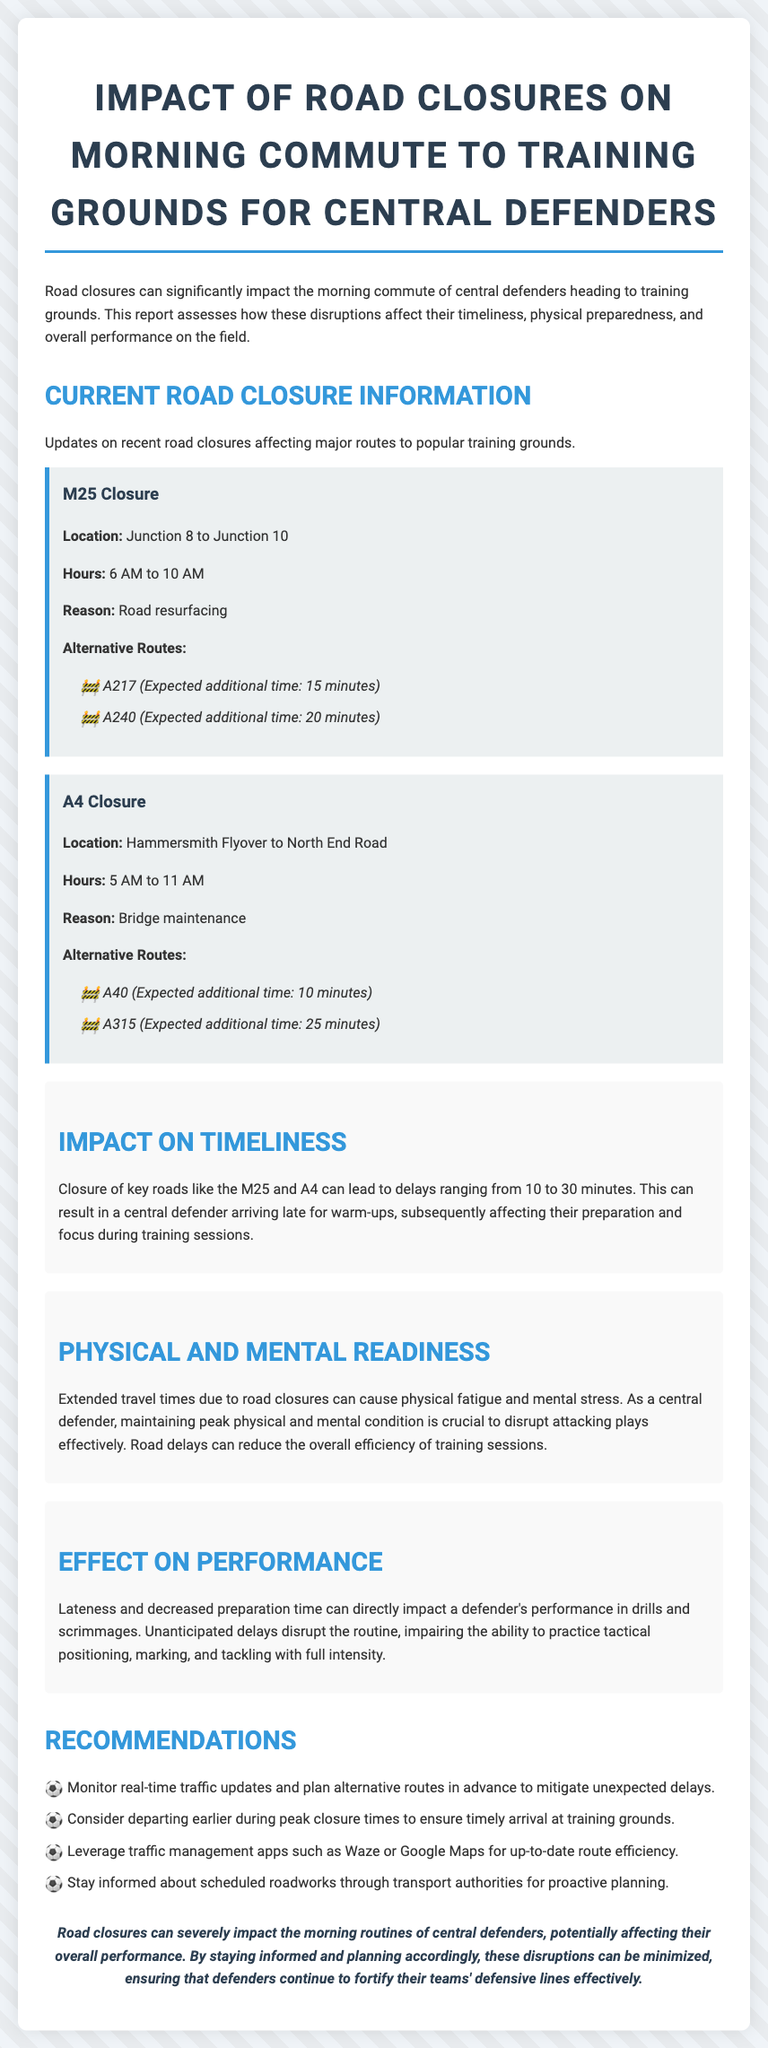What is the reason for the M25 closure? The document states that the reason for the M25 closure is road resurfacing.
Answer: road resurfacing What are the expected additional times for the A217 alternative route? According to the document, the expected additional time for the A217 alternative route is 15 minutes.
Answer: 15 minutes What are the closure hours for the A4? The A4 closure hours are detailed in the document as 5 AM to 11 AM.
Answer: 5 AM to 11 AM How does road closure impact timeliness? The document explains that road closures can lead to delays ranging from 10 to 30 minutes, affecting arrival times for warm-ups.
Answer: 10 to 30 minutes What is a recommended action for central defenders? The document recommends that central defenders should monitor real-time traffic updates and plan alternative routes in advance.
Answer: monitor real-time traffic updates What effect do road closures have on a defender's performance in drills? According to the report, lateness and decreased preparation time can directly impact a defender's performance in drills and scrimmages.
Answer: directly impact performance What is the location of the A4 closure? The A4 closure is located from Hammersmith Flyover to North End Road.
Answer: Hammersmith Flyover to North End Road What background color is used for the impact sections? The background color of the impact sections is specified in the document as light gray (#f9f9f9).
Answer: light gray What should central defenders leverage for traffic updates? The document suggests leveraging traffic management apps such as Waze or Google Maps for up-to-date route efficiency.
Answer: Waze or Google Maps 